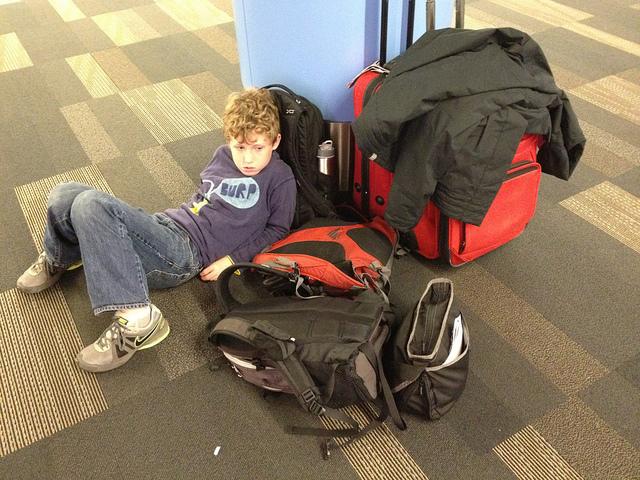Would this picture indicate that the boy is traveling alone?
Quick response, please. No. Does the kid look bored?
Write a very short answer. Yes. What is in the word bubble on the boy's shirt?
Give a very brief answer. Burp. 